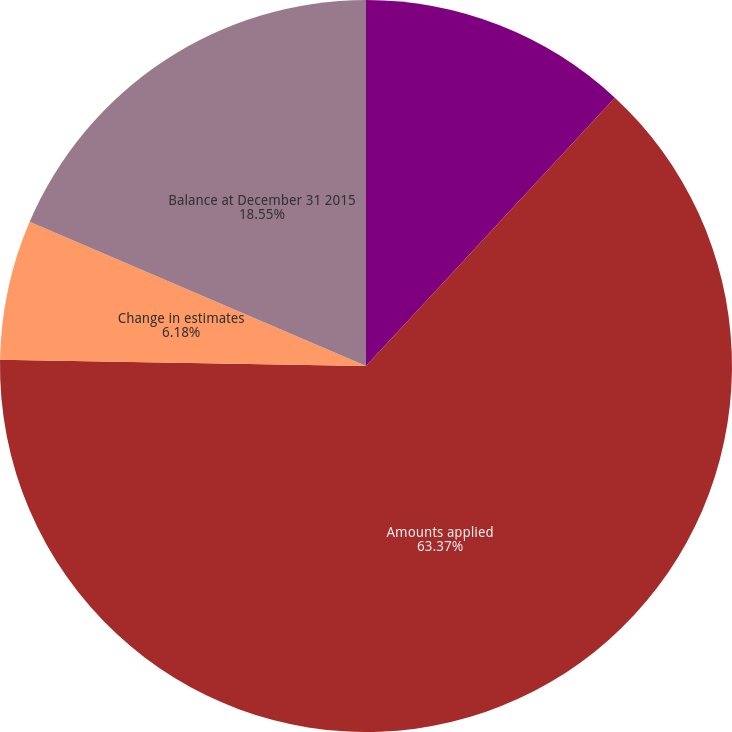<chart> <loc_0><loc_0><loc_500><loc_500><pie_chart><fcel>Provisions and adjustments<fcel>Amounts applied<fcel>Change in estimates<fcel>Balance at December 31 2015<nl><fcel>11.9%<fcel>63.37%<fcel>6.18%<fcel>18.55%<nl></chart> 